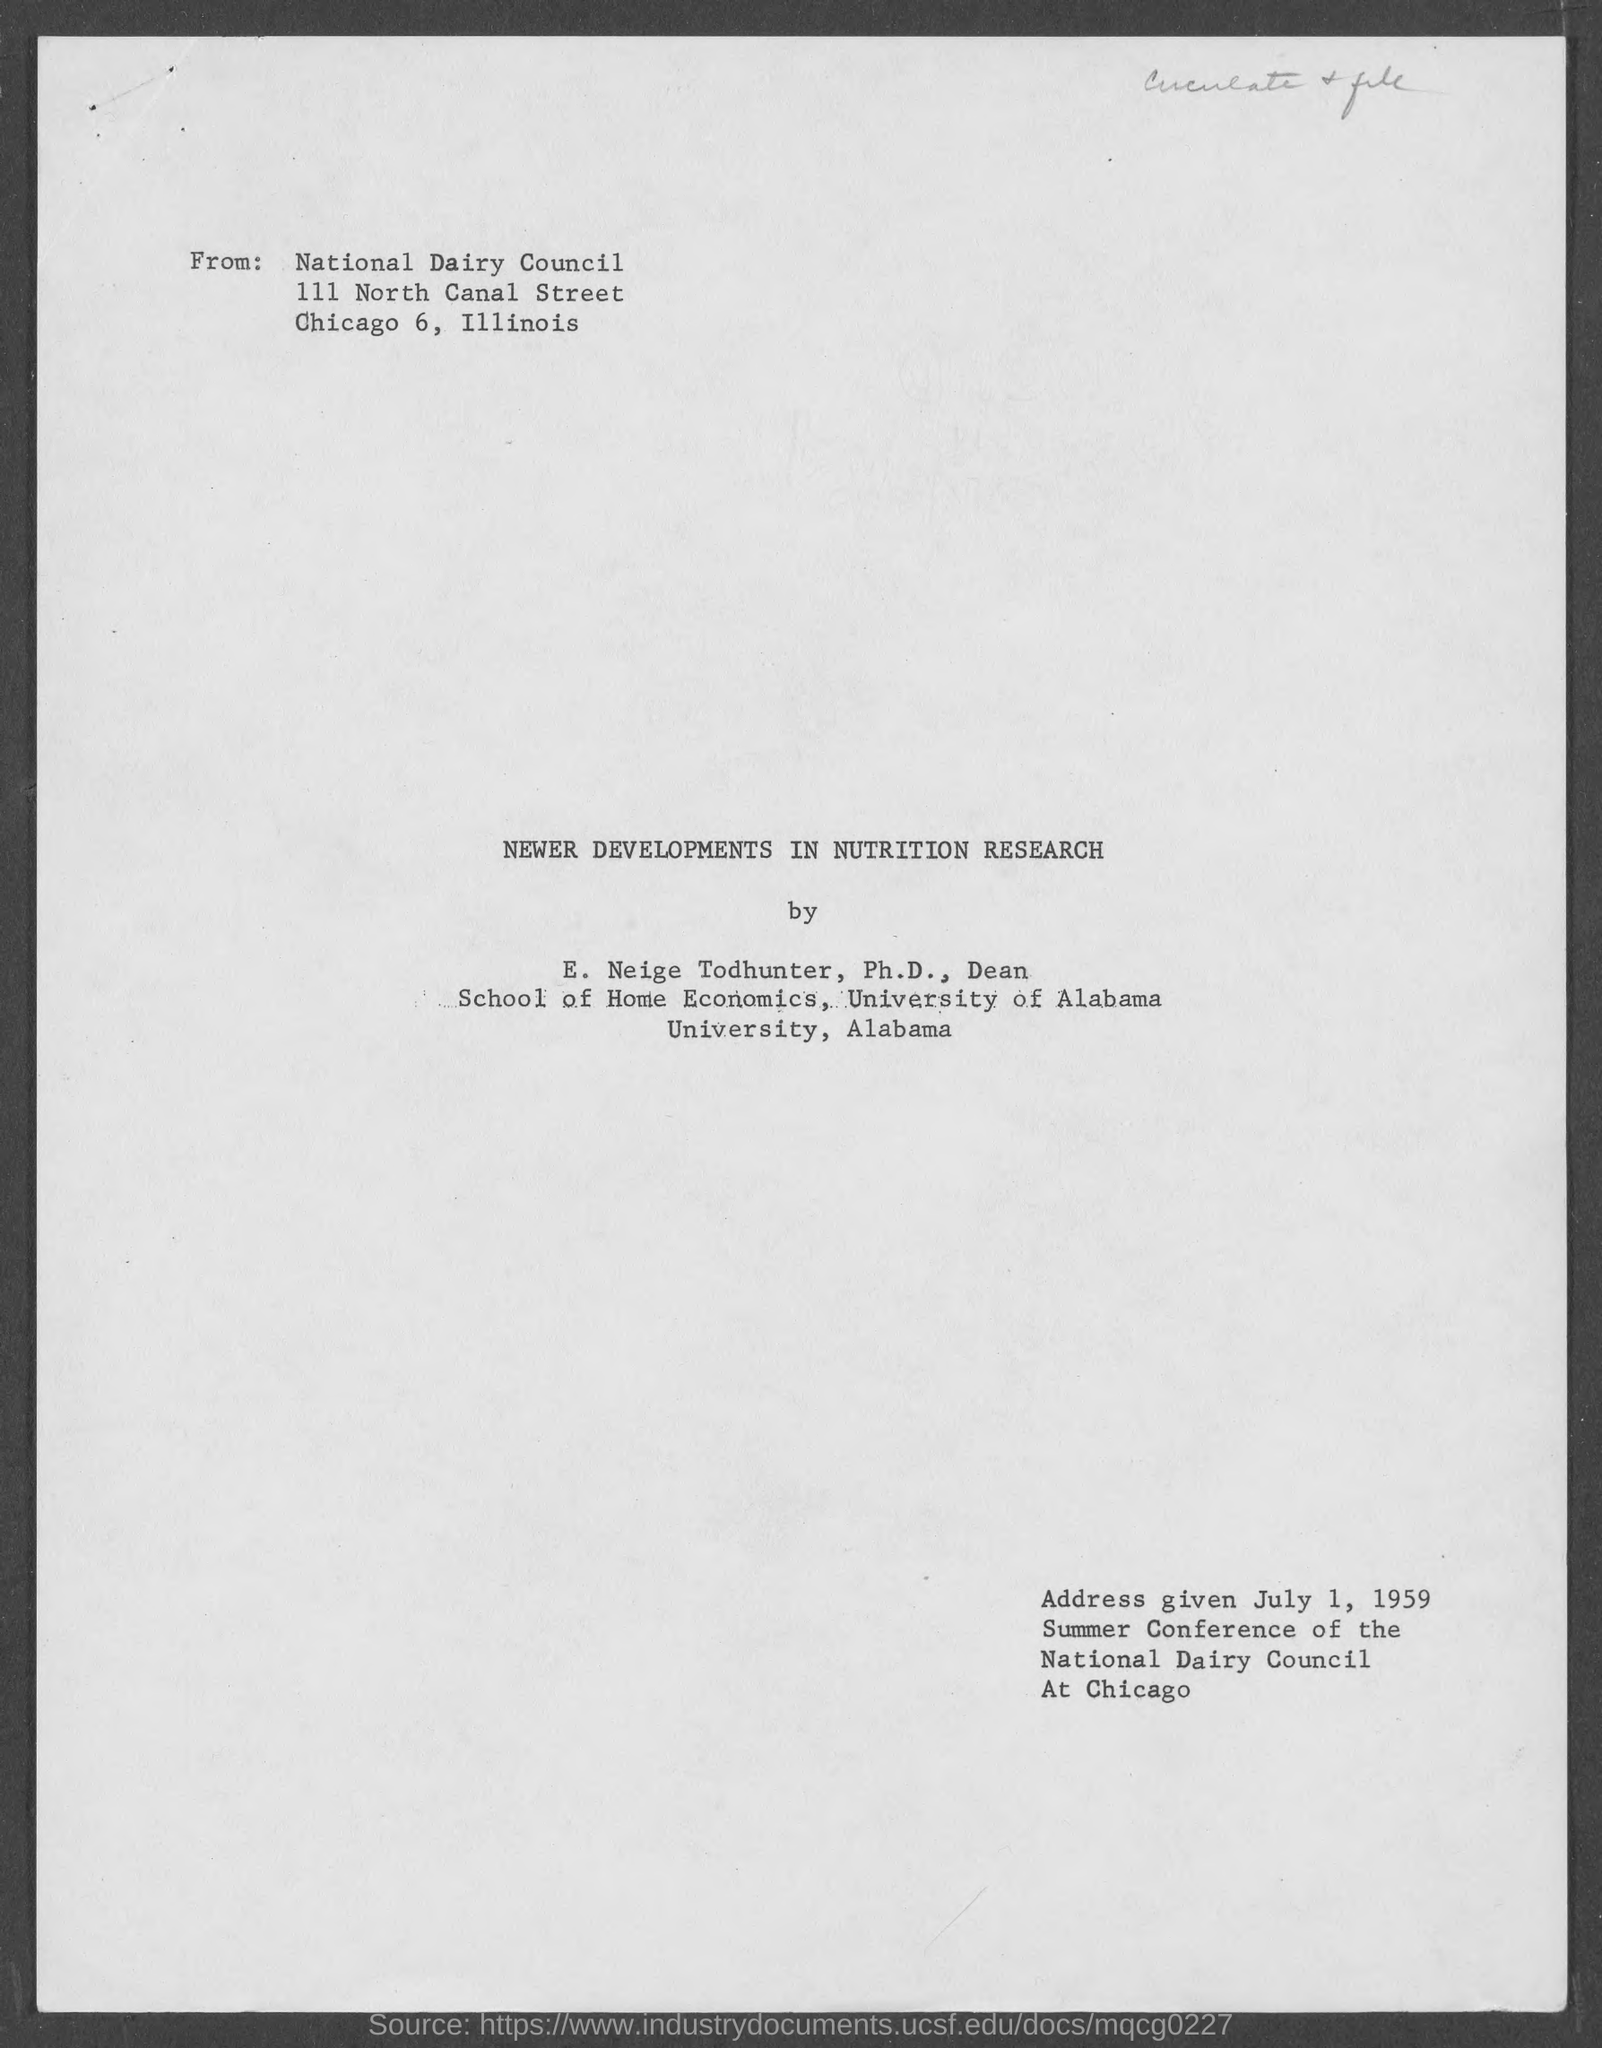What is the title of the given document?
Ensure brevity in your answer.  Newer developments in nutrition research. 